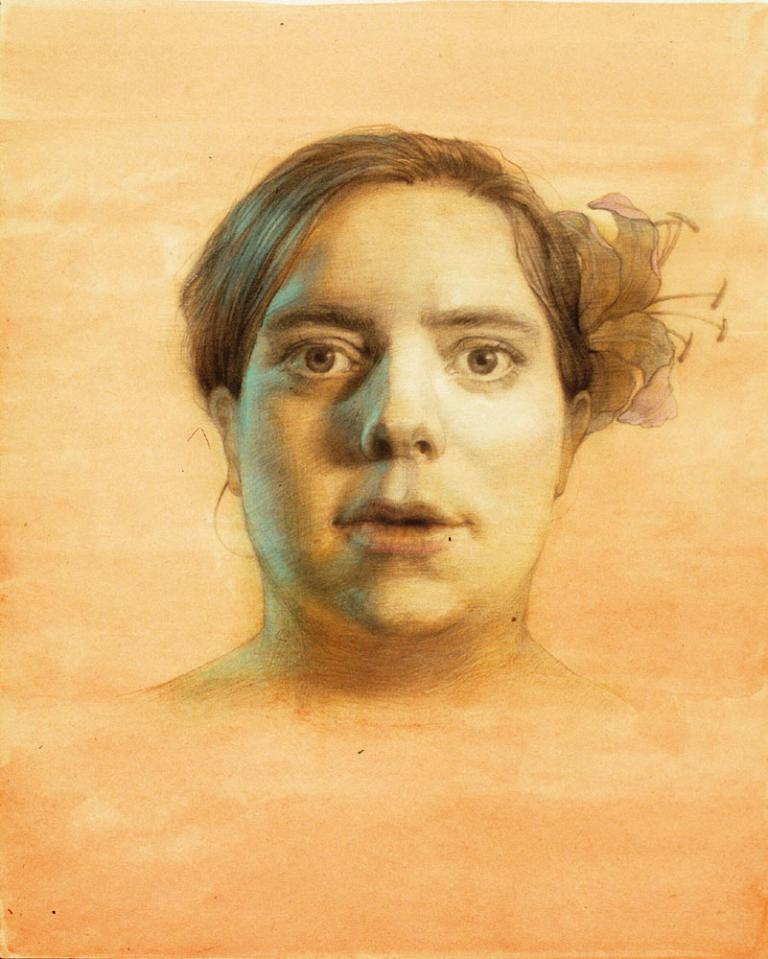Who is the main subject in the image? The main subject in the image is a woman. What can be observed about the background of the image? The background of the image is in light orange color. Is the woman experiencing any pain in the image? There is no indication of pain in the image, as it only shows a woman and the background color. 